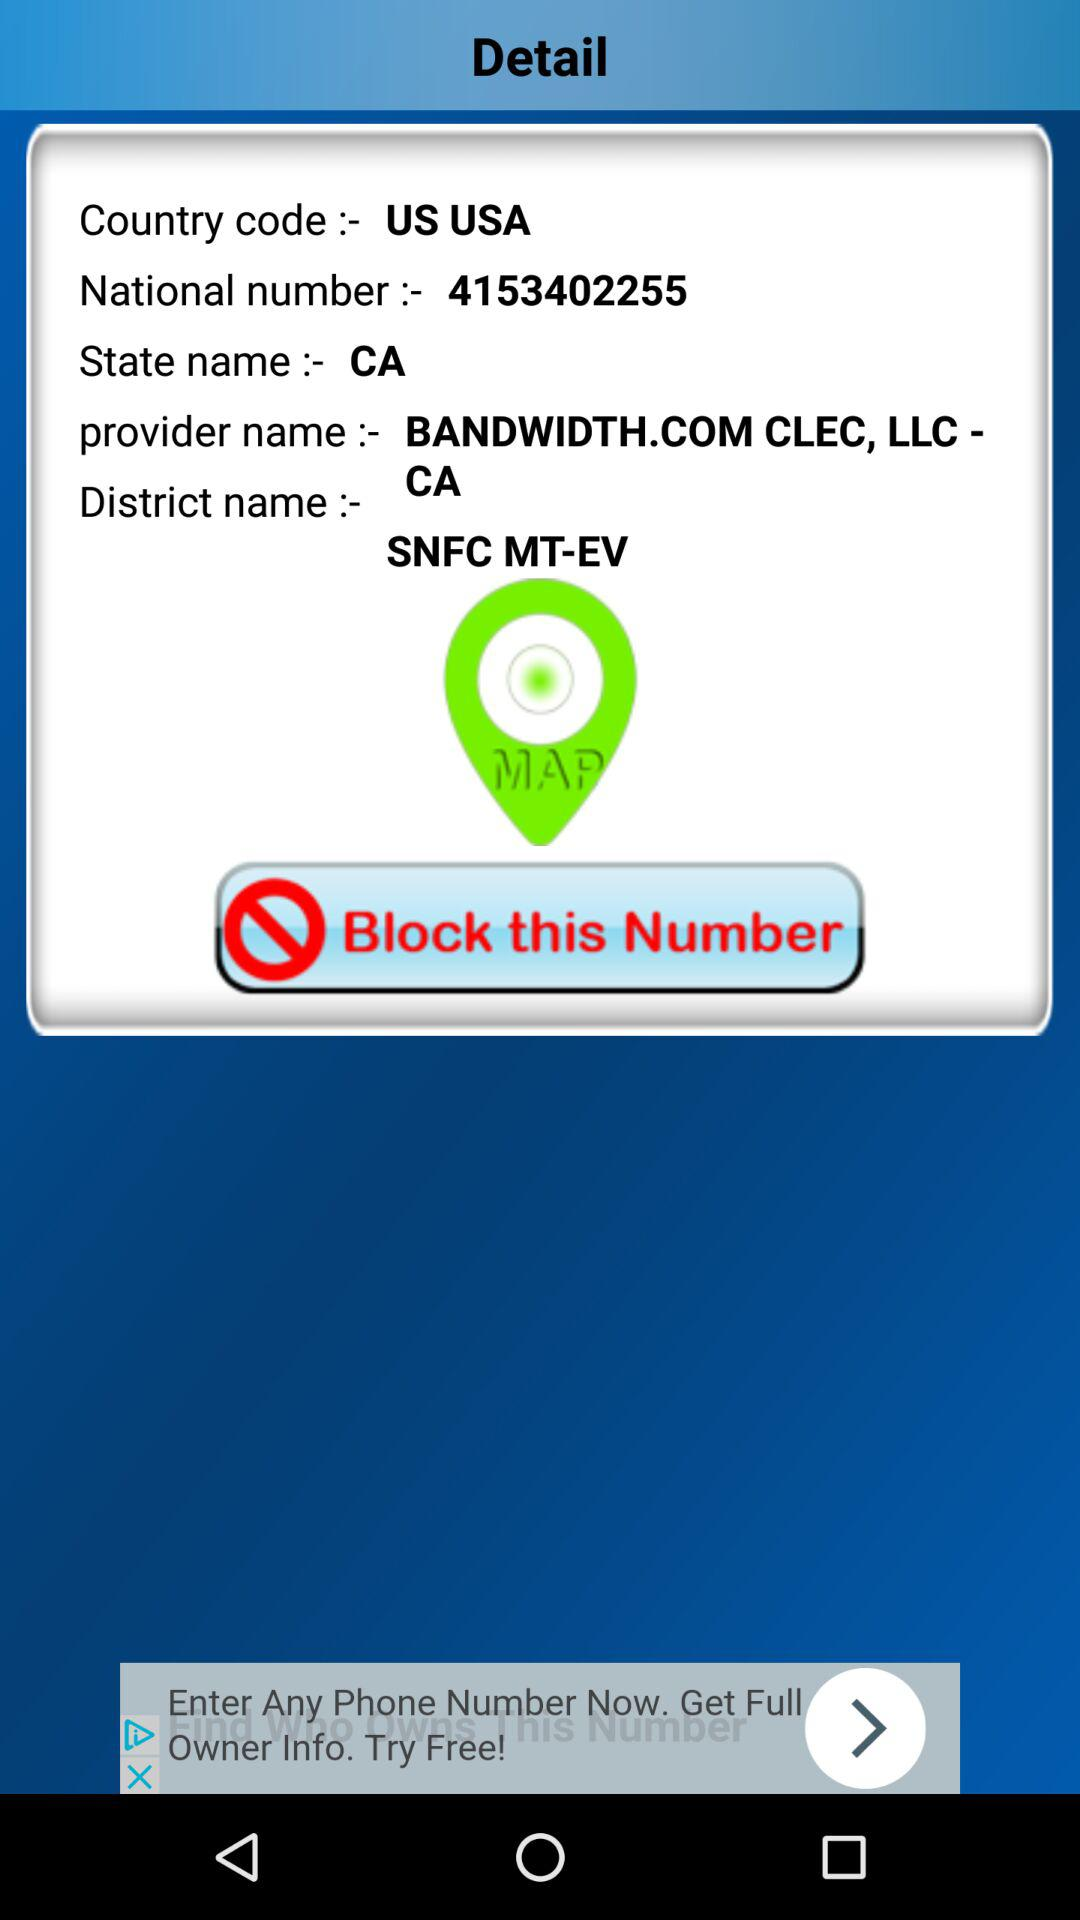What is the country code? The country code is "US USA". 